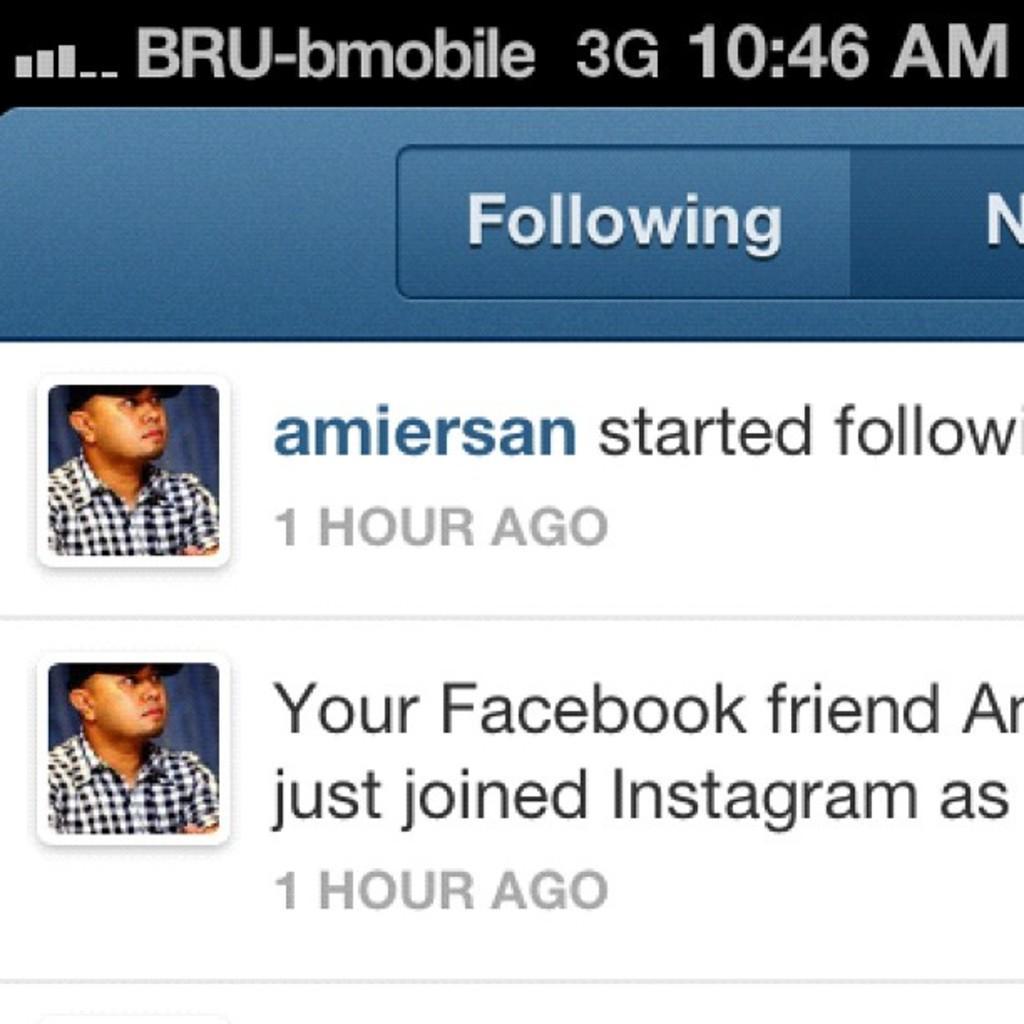In one or two sentences, can you explain what this image depicts? In this image we can see the mobile screen with the text and also the person images. 